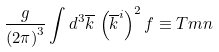<formula> <loc_0><loc_0><loc_500><loc_500>\frac { g } { \left ( 2 \pi \right ) ^ { 3 } } \int d ^ { 3 } \overline { k } \, \left ( \overline { k } ^ { i } \right ) ^ { 2 } f \equiv T m n</formula> 